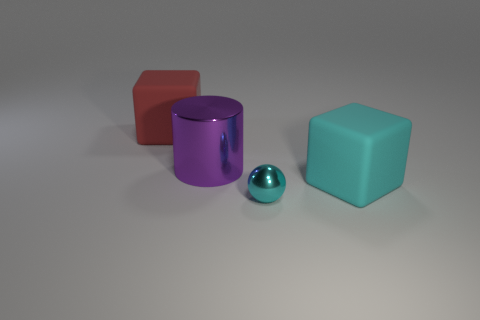Add 2 large red matte cubes. How many objects exist? 6 Subtract all spheres. How many objects are left? 3 Add 4 balls. How many balls are left? 5 Add 1 yellow rubber things. How many yellow rubber things exist? 1 Subtract 0 gray cubes. How many objects are left? 4 Subtract all purple cubes. Subtract all purple cylinders. How many cubes are left? 2 Subtract all large purple metallic things. Subtract all cyan objects. How many objects are left? 1 